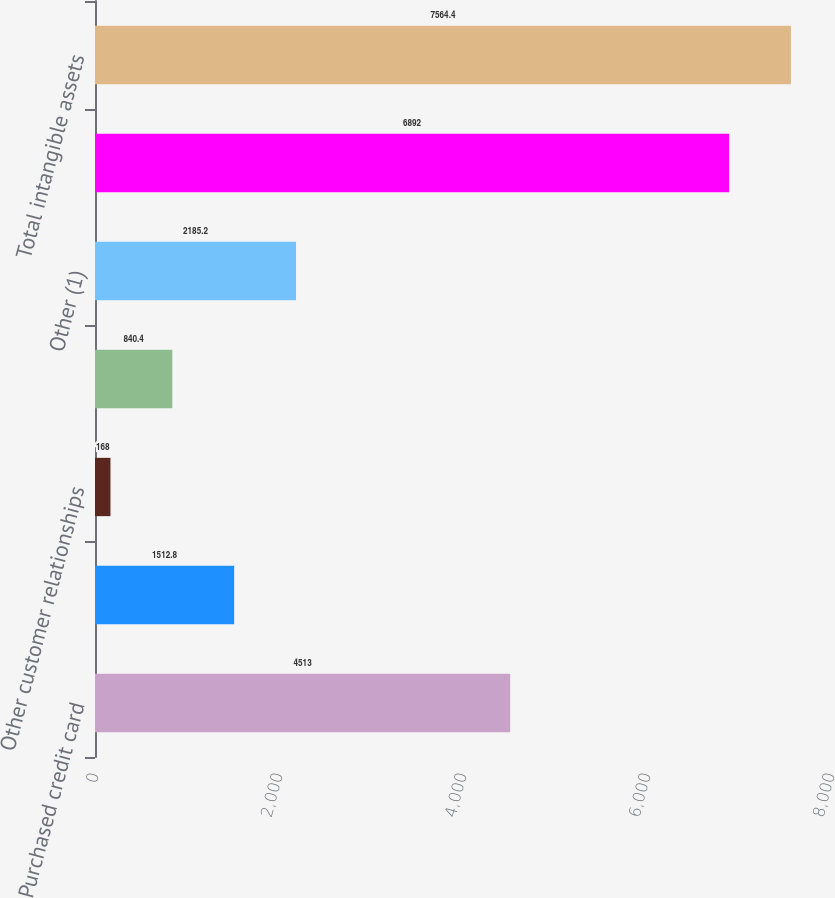Convert chart to OTSL. <chart><loc_0><loc_0><loc_500><loc_500><bar_chart><fcel>Purchased credit card<fcel>Core deposit intangibles<fcel>Other customer relationships<fcel>Present value of future<fcel>Other (1)<fcel>Total amortizing intangible<fcel>Total intangible assets<nl><fcel>4513<fcel>1512.8<fcel>168<fcel>840.4<fcel>2185.2<fcel>6892<fcel>7564.4<nl></chart> 